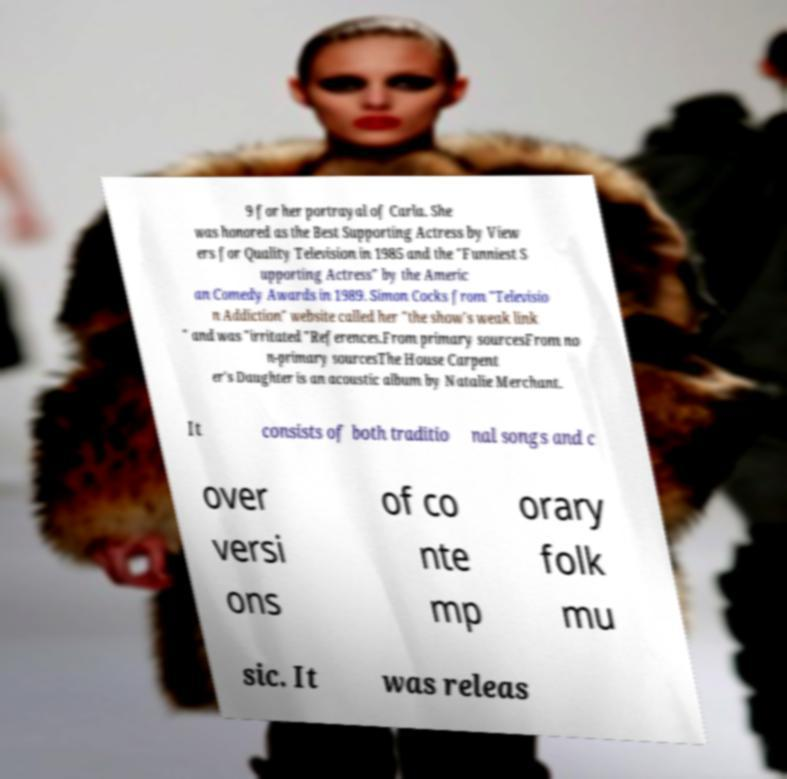Please identify and transcribe the text found in this image. 9 for her portrayal of Carla. She was honored as the Best Supporting Actress by View ers for Quality Television in 1985 and the "Funniest S upporting Actress" by the Americ an Comedy Awards in 1989. Simon Cocks from "Televisio n Addiction" website called her "the show's weak link " and was "irritated "References.From primary sourcesFrom no n-primary sourcesThe House Carpent er's Daughter is an acoustic album by Natalie Merchant. It consists of both traditio nal songs and c over versi ons of co nte mp orary folk mu sic. It was releas 